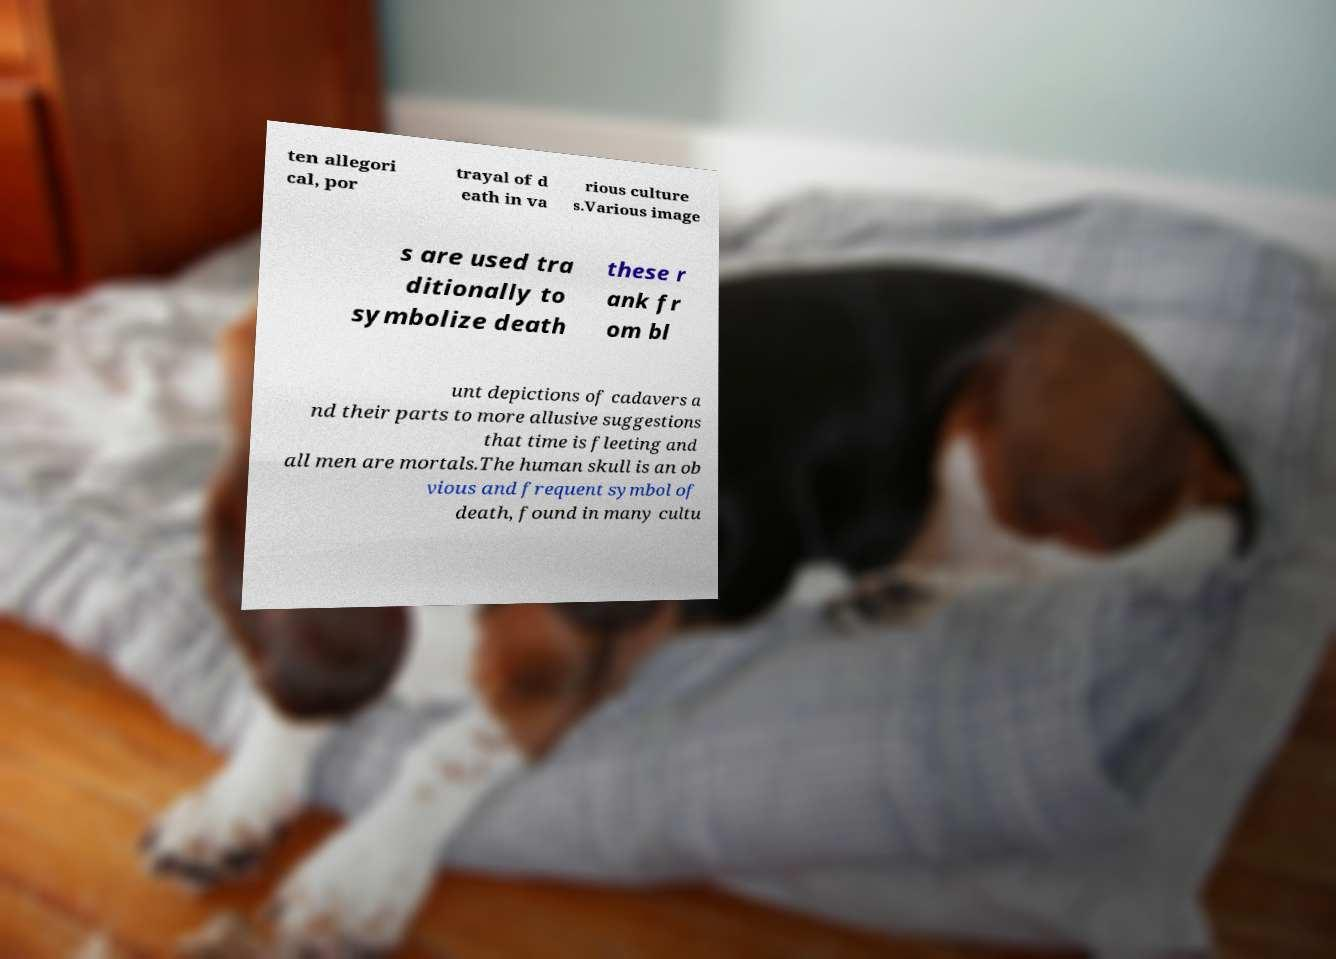Can you accurately transcribe the text from the provided image for me? ten allegori cal, por trayal of d eath in va rious culture s.Various image s are used tra ditionally to symbolize death these r ank fr om bl unt depictions of cadavers a nd their parts to more allusive suggestions that time is fleeting and all men are mortals.The human skull is an ob vious and frequent symbol of death, found in many cultu 